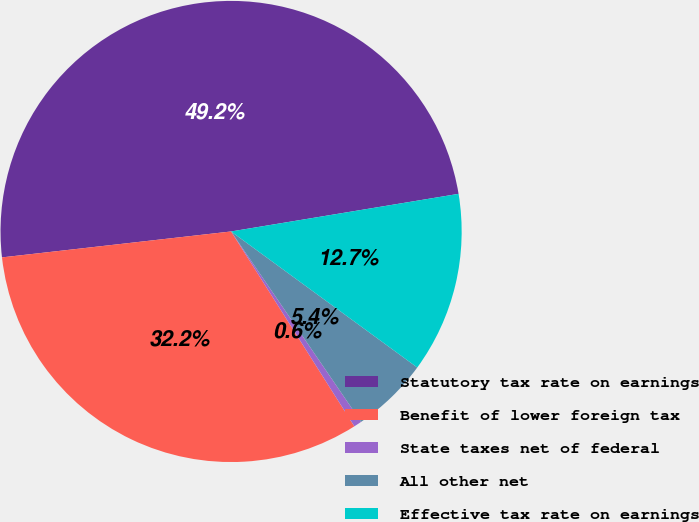Convert chart. <chart><loc_0><loc_0><loc_500><loc_500><pie_chart><fcel>Statutory tax rate on earnings<fcel>Benefit of lower foreign tax<fcel>State taxes net of federal<fcel>All other net<fcel>Effective tax rate on earnings<nl><fcel>49.18%<fcel>32.18%<fcel>0.56%<fcel>5.42%<fcel>12.65%<nl></chart> 